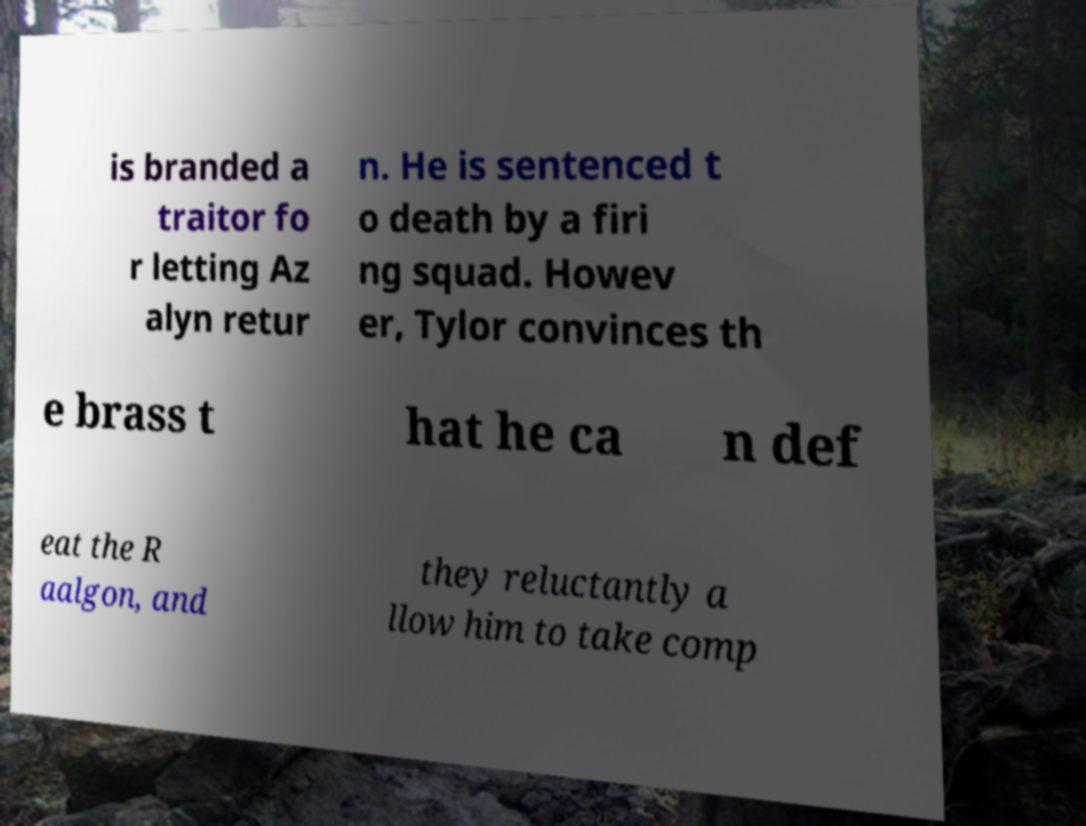Could you extract and type out the text from this image? is branded a traitor fo r letting Az alyn retur n. He is sentenced t o death by a firi ng squad. Howev er, Tylor convinces th e brass t hat he ca n def eat the R aalgon, and they reluctantly a llow him to take comp 